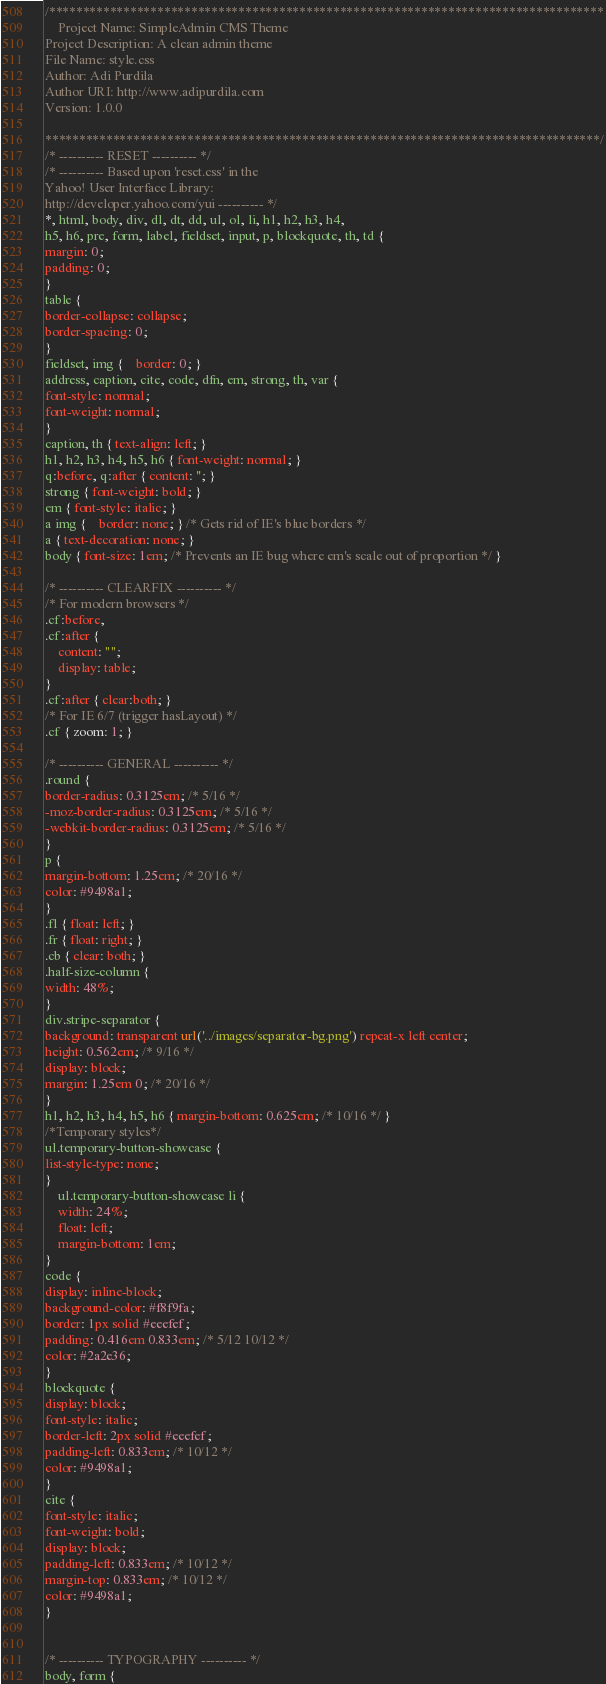<code> <loc_0><loc_0><loc_500><loc_500><_CSS_>/**********************************************************************************
	Project Name: SimpleAdmin CMS Theme
Project Description: A clean admin theme
File Name: style.css
Author: Adi Purdila
Author URI: http://www.adipurdila.com
Version: 1.0.0

**********************************************************************************/
/* ---------- RESET ---------- */
/* ---------- Based upon 'reset.css' in the 
Yahoo! User Interface Library: 
http://developer.yahoo.com/yui ---------- */
*, html, body, div, dl, dt, dd, ul, ol, li, h1, h2, h3, h4, 
h5, h6, pre, form, label, fieldset, input, p, blockquote, th, td {
margin: 0;
padding: 0;
}
table {
border-collapse: collapse;
border-spacing: 0;
}
fieldset, img {	border: 0; }
address, caption, cite, code, dfn, em, strong, th, var {
font-style: normal;
font-weight: normal;
}
caption, th { text-align: left; }
h1, h2, h3, h4, h5, h6 { font-weight: normal; }
q:before, q:after { content: ''; }
strong { font-weight: bold; }
em { font-style: italic; }
a img {	border: none; } /* Gets rid of IE's blue borders */
a { text-decoration: none; }
body { font-size: 1em; /* Prevents an IE bug where em's scale out of proportion */ }

/* ---------- CLEARFIX ---------- */
/* For modern browsers */
.cf:before,
.cf:after {
    content: "";
    display: table;
}
.cf:after { clear:both; }
/* For IE 6/7 (trigger hasLayout) */
.cf { zoom: 1; }

/* ---------- GENERAL ---------- */
.round {
border-radius: 0.3125em; /* 5/16 */
-moz-border-radius: 0.3125em; /* 5/16 */
-webkit-border-radius: 0.3125em; /* 5/16 */
}
p {
margin-bottom: 1.25em; /* 20/16 */
color: #9498a1;
}
.fl { float: left; }
.fr { float: right; }
.cb { clear: both; }
.half-size-column {
width: 48%;
}
div.stripe-separator {
background: transparent url('../images/separator-bg.png') repeat-x left center;
height: 0.562em; /* 9/16 */
display: block;
margin: 1.25em 0; /* 20/16 */
}
h1, h2, h3, h4, h5, h6 { margin-bottom: 0.625em; /* 10/16 */ }
/*Temporary styles*/
ul.temporary-button-showcase {
list-style-type: none;
}
	ul.temporary-button-showcase li {
	width: 24%;
	float: left;
	margin-bottom: 1em;
}
code {
display: inline-block;
background-color: #f8f9fa;
border: 1px solid #eeefef;
padding: 0.416em 0.833em; /* 5/12 10/12 */
color: #2a2e36;
}
blockquote {
display: block;
font-style: italic;
border-left: 2px solid #eeefef;
padding-left: 0.833em; /* 10/12 */
color: #9498a1;
}
cite {
font-style: italic;
font-weight: bold;
display: block;
padding-left: 0.833em; /* 10/12 */
margin-top: 0.833em; /* 10/12 */
color: #9498a1;
}


/* ---------- TYPOGRAPHY ---------- */
body, form {</code> 